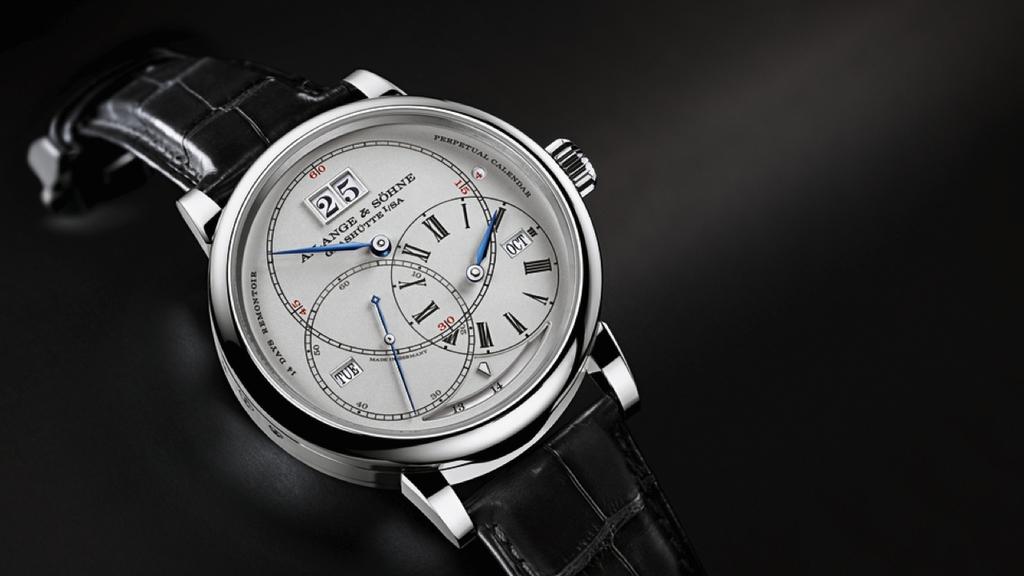What is the day of the month on the watch?
Give a very brief answer. 25. What time is it?
Offer a very short reply. 2:50. 